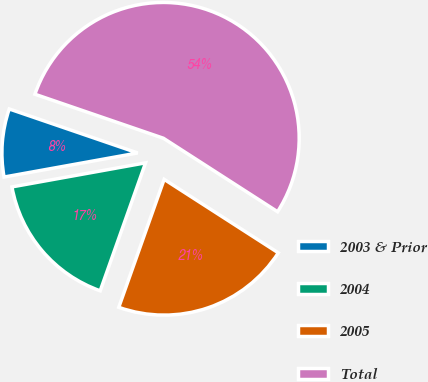Convert chart. <chart><loc_0><loc_0><loc_500><loc_500><pie_chart><fcel>2003 & Prior<fcel>2004<fcel>2005<fcel>Total<nl><fcel>8.09%<fcel>16.74%<fcel>21.32%<fcel>53.85%<nl></chart> 